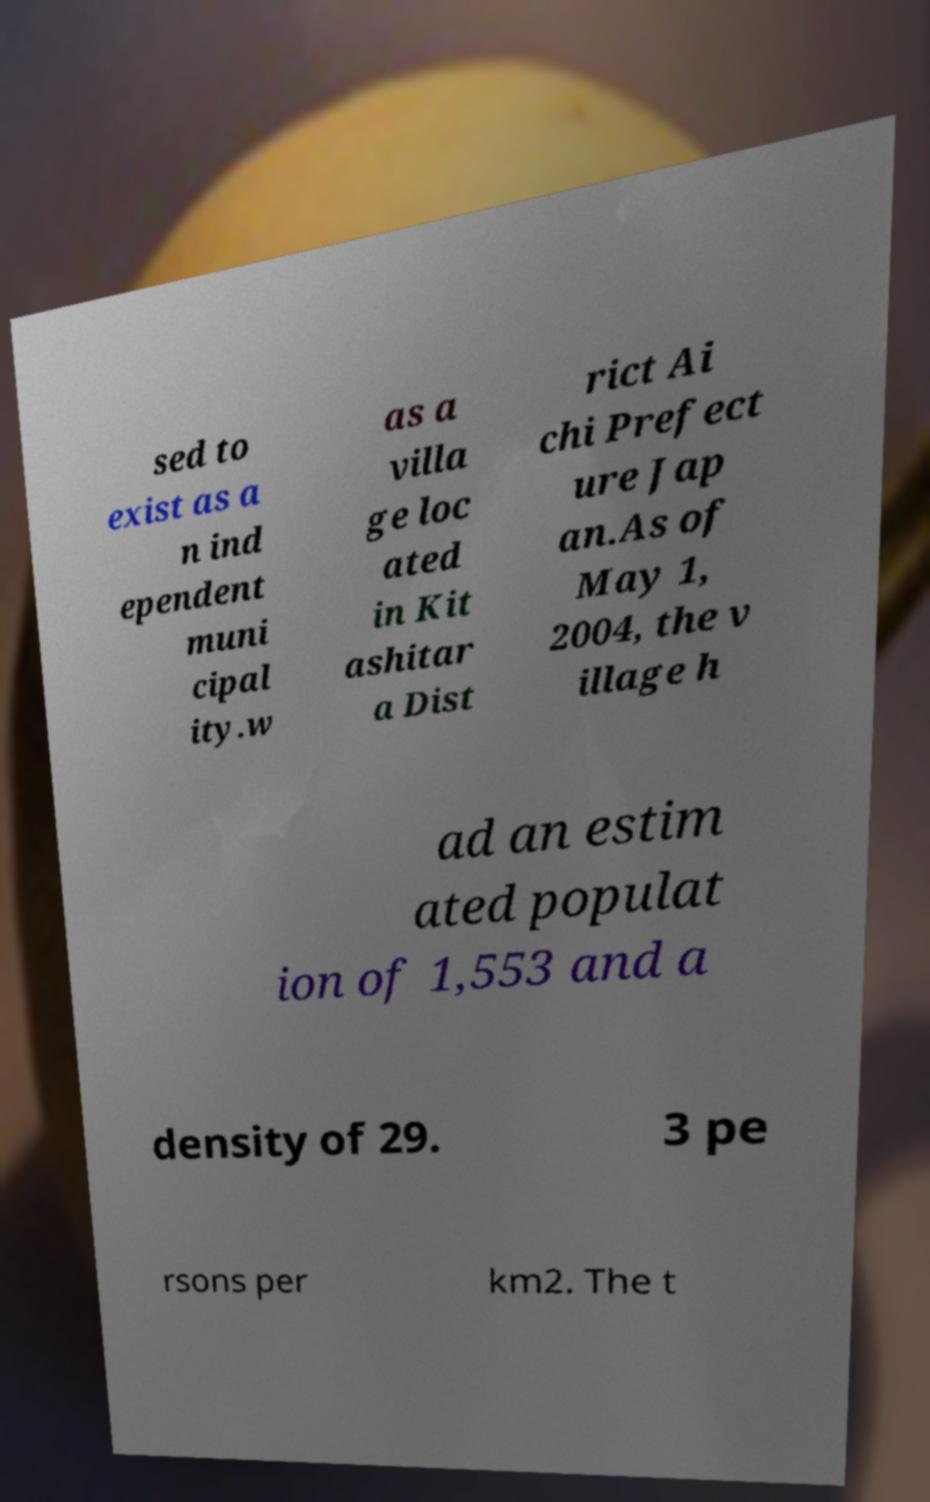Could you extract and type out the text from this image? sed to exist as a n ind ependent muni cipal ity.w as a villa ge loc ated in Kit ashitar a Dist rict Ai chi Prefect ure Jap an.As of May 1, 2004, the v illage h ad an estim ated populat ion of 1,553 and a density of 29. 3 pe rsons per km2. The t 